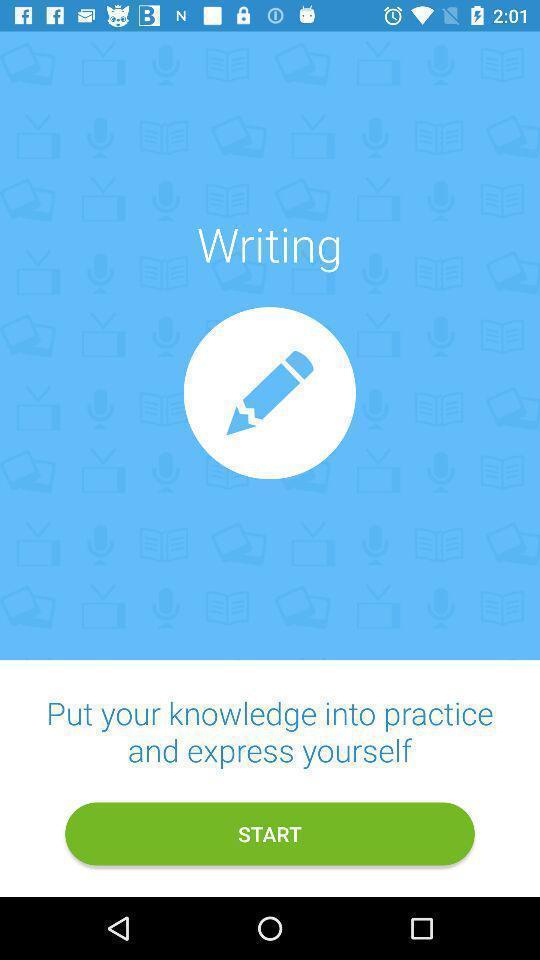Summarize the information in this screenshot. Welcome page with start option. 